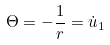Convert formula to latex. <formula><loc_0><loc_0><loc_500><loc_500>\Theta = - \frac { 1 } { r } = \dot { u } _ { 1 }</formula> 